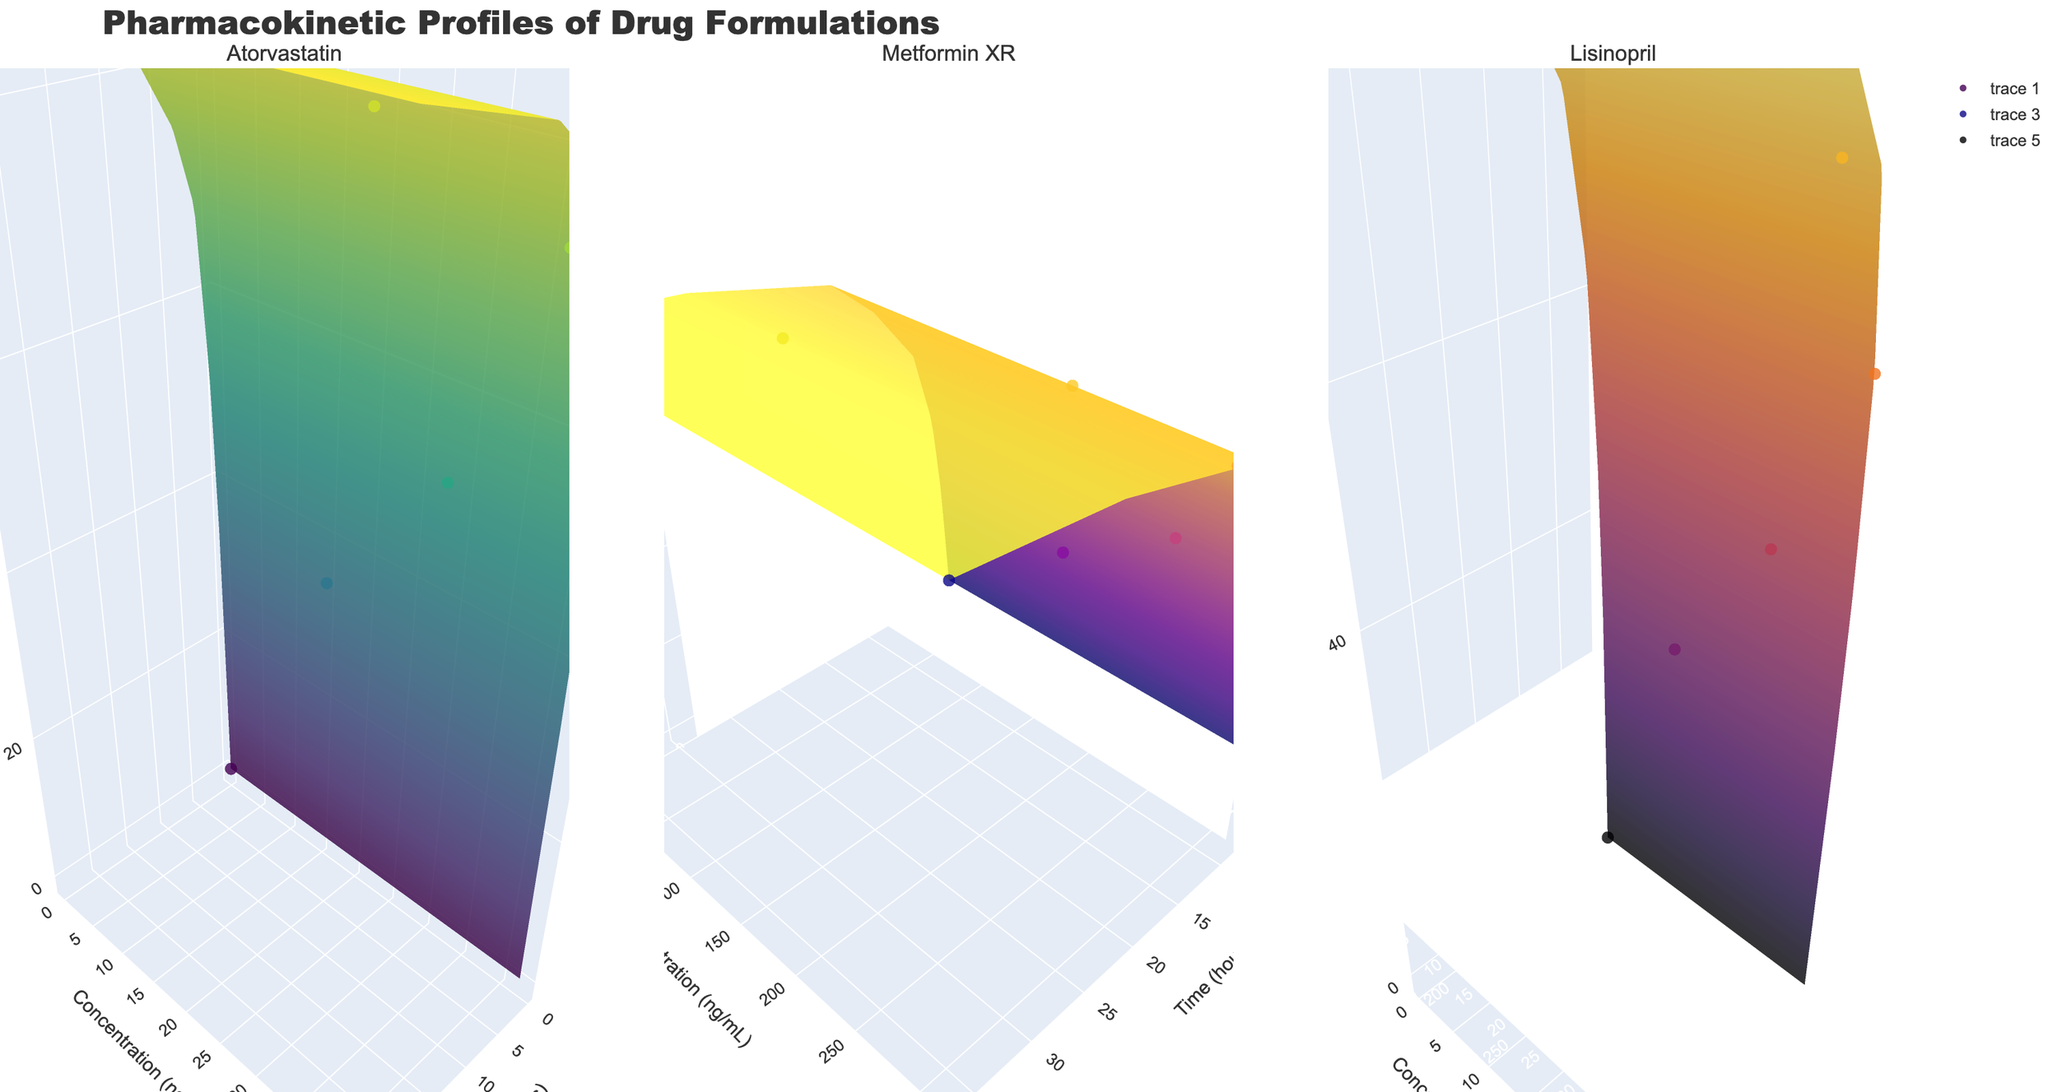What is the title of the figure? The title of the figure is displayed at the top of the chart. It is directly labeled as "Pharmacokinetic Profiles of Drug Formulations".
Answer: Pharmacokinetic Profiles of Drug Formulations How many subplots are there in the figure? The figure has three separate 3D surface plots, as shown by the three different sections each titled with a drug name.
Answer: 3 What is the range of Bioavailability (%) for Atorvastatin displayed on the plot? The 3D plot ranges from 0% to a maximum of 88% as indicated by the z-axis for the Atorvastatin subplot.
Answer: 0% to 88% At 1 hour, which drug has the highest concentration (ng/mL)? Observing the plots, for Atorvastatin it is 28.7 ng/mL, for Metformin XR it is 120.5 ng/mL, and for Lisinopril it is 18.2 ng/mL. Hence, Metformin XR has the highest concentration at 1 hour.
Answer: Metformin XR What is the shape of the bioavailability curve for Metformin XR over time? The Bioavailability (%) increases over time in the 3D plot for Metformin XR, which starts at 0% and reaches 88% gradually, indicating a steady upward slope in the bioavailability curve.
Answer: Steady upward slope Which drug formulation reaches its highest concentration the fastest? By examining the 3D plots, Atorvastatin reaches its peak concentration around 2 hours, Metformin XR around 4 hours, and Lisinopril around 2-4 hours. Therefore, Atorvastatin reaches its highest concentration the fastest.
Answer: Atorvastatin Which drug seems to have the most prolonged bioavailability profile? By observing the figures, Metformin XR maintains its higher bioavailability for a more extended period; it continues to increase and remains high for up to 36 hours. This is more prolonged compared to the other drugs.
Answer: Metformin XR Compare the bioavailability at 12 hours between Lisinopril and Atorvastatin. According to the 3D plots, at 12 hours, Lisinopril has a bioavailability of 86%, whereas Atorvastatin has a bioavailability of 85%, from their respective z-axis values.
Answer: Lisinopril has slightly higher bioavailability at 12 hours What is the average concentration (ng/mL) of Lisinopril? The concentrations for Lisinopril over time are 0, 8.7, 18.2, 25.6, 22.9, 15.4, 9.8, 3.1 ng/mL. The average is therefore (0 + 8.7 + 18.2 + 25.6 + 22.9 + 15.4 + 9.8 + 3.1) / 8 ≈ 13 ng/mL.
Answer: 13 ng/mL Which drug shows the greatest variability in bioavailability? By analyzing the plots, Metformin XR shows the greatest variability; it starts at 0% and ends at 88%, with bioavailability spreading over a large range across the time points.
Answer: Metformin XR 